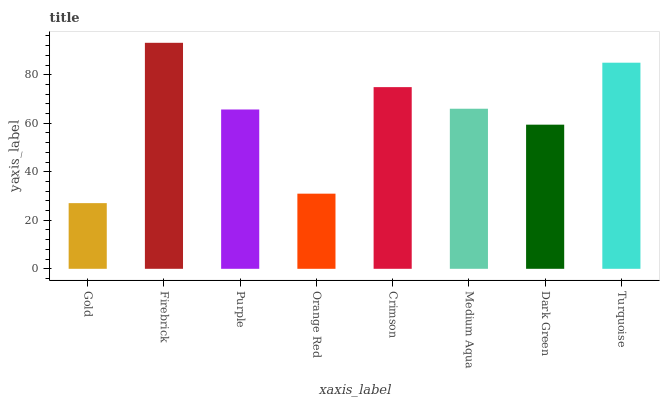Is Gold the minimum?
Answer yes or no. Yes. Is Firebrick the maximum?
Answer yes or no. Yes. Is Purple the minimum?
Answer yes or no. No. Is Purple the maximum?
Answer yes or no. No. Is Firebrick greater than Purple?
Answer yes or no. Yes. Is Purple less than Firebrick?
Answer yes or no. Yes. Is Purple greater than Firebrick?
Answer yes or no. No. Is Firebrick less than Purple?
Answer yes or no. No. Is Medium Aqua the high median?
Answer yes or no. Yes. Is Purple the low median?
Answer yes or no. Yes. Is Gold the high median?
Answer yes or no. No. Is Firebrick the low median?
Answer yes or no. No. 